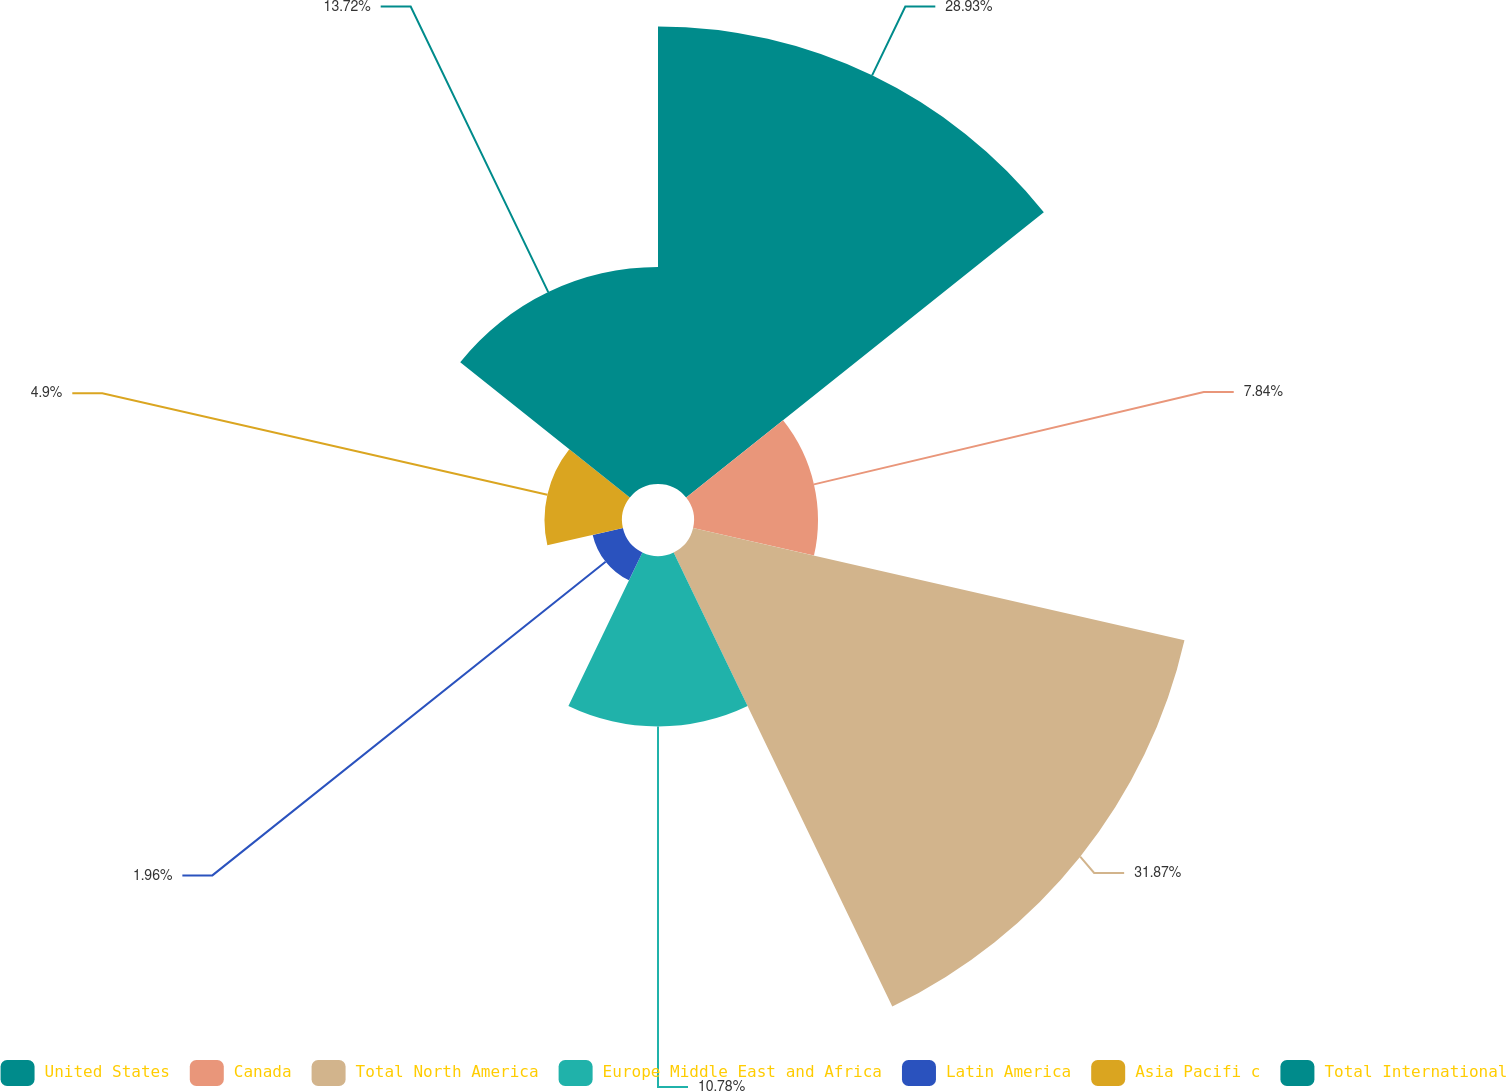Convert chart. <chart><loc_0><loc_0><loc_500><loc_500><pie_chart><fcel>United States<fcel>Canada<fcel>Total North America<fcel>Europe Middle East and Africa<fcel>Latin America<fcel>Asia Pacifi c<fcel>Total International<nl><fcel>28.93%<fcel>7.84%<fcel>31.87%<fcel>10.78%<fcel>1.96%<fcel>4.9%<fcel>13.72%<nl></chart> 